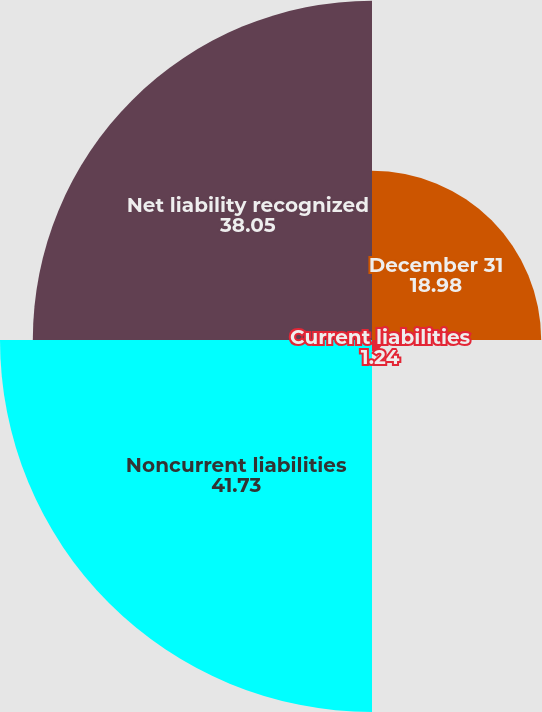<chart> <loc_0><loc_0><loc_500><loc_500><pie_chart><fcel>December 31<fcel>Current liabilities<fcel>Noncurrent liabilities<fcel>Net liability recognized<nl><fcel>18.98%<fcel>1.24%<fcel>41.73%<fcel>38.05%<nl></chart> 